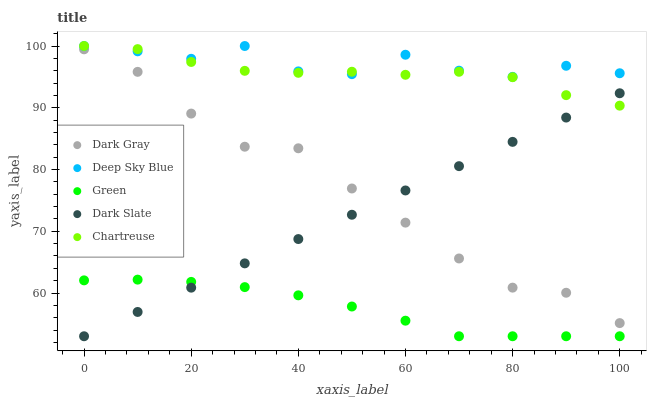Does Green have the minimum area under the curve?
Answer yes or no. Yes. Does Deep Sky Blue have the maximum area under the curve?
Answer yes or no. Yes. Does Dark Slate have the minimum area under the curve?
Answer yes or no. No. Does Dark Slate have the maximum area under the curve?
Answer yes or no. No. Is Dark Slate the smoothest?
Answer yes or no. Yes. Is Deep Sky Blue the roughest?
Answer yes or no. Yes. Is Chartreuse the smoothest?
Answer yes or no. No. Is Chartreuse the roughest?
Answer yes or no. No. Does Dark Slate have the lowest value?
Answer yes or no. Yes. Does Chartreuse have the lowest value?
Answer yes or no. No. Does Deep Sky Blue have the highest value?
Answer yes or no. Yes. Does Dark Slate have the highest value?
Answer yes or no. No. Is Green less than Dark Gray?
Answer yes or no. Yes. Is Deep Sky Blue greater than Dark Slate?
Answer yes or no. Yes. Does Green intersect Dark Slate?
Answer yes or no. Yes. Is Green less than Dark Slate?
Answer yes or no. No. Is Green greater than Dark Slate?
Answer yes or no. No. Does Green intersect Dark Gray?
Answer yes or no. No. 